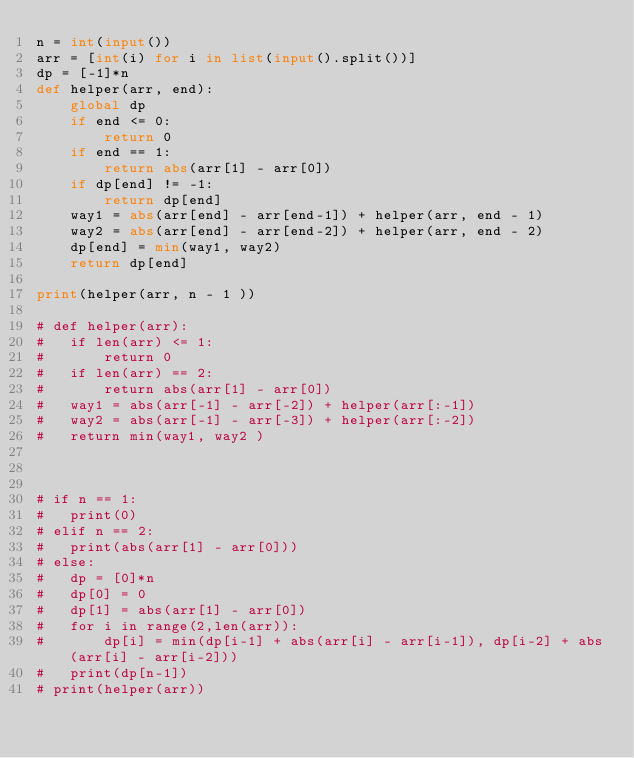Convert code to text. <code><loc_0><loc_0><loc_500><loc_500><_Python_>n = int(input())
arr = [int(i) for i in list(input().split())]
dp = [-1]*n
def helper(arr, end):
	global dp
	if end <= 0:
		return 0 
	if end == 1:
		return abs(arr[1] - arr[0])
	if dp[end] != -1:
		return dp[end]
	way1 = abs(arr[end] - arr[end-1]) + helper(arr, end - 1)
	way2 = abs(arr[end] - arr[end-2]) + helper(arr, end - 2)
	dp[end] = min(way1, way2)
	return dp[end]

print(helper(arr, n - 1 ))

# def helper(arr):
# 	if len(arr) <= 1:
# 		return 0
# 	if len(arr) == 2:
# 		return abs(arr[1] - arr[0])
# 	way1 = abs(arr[-1] - arr[-2]) + helper(arr[:-1])
# 	way2 = abs(arr[-1] - arr[-3]) + helper(arr[:-2])
# 	return min(way1, way2 )



# if n == 1:
# 	print(0)
# elif n == 2:
# 	print(abs(arr[1] - arr[0]))
# else:
# 	dp = [0]*n
# 	dp[0] = 0
# 	dp[1] = abs(arr[1] - arr[0])
# 	for i in range(2,len(arr)):
# 		dp[i] = min(dp[i-1] + abs(arr[i] - arr[i-1]), dp[i-2] + abs(arr[i] - arr[i-2]))
# 	print(dp[n-1])
# print(helper(arr))</code> 